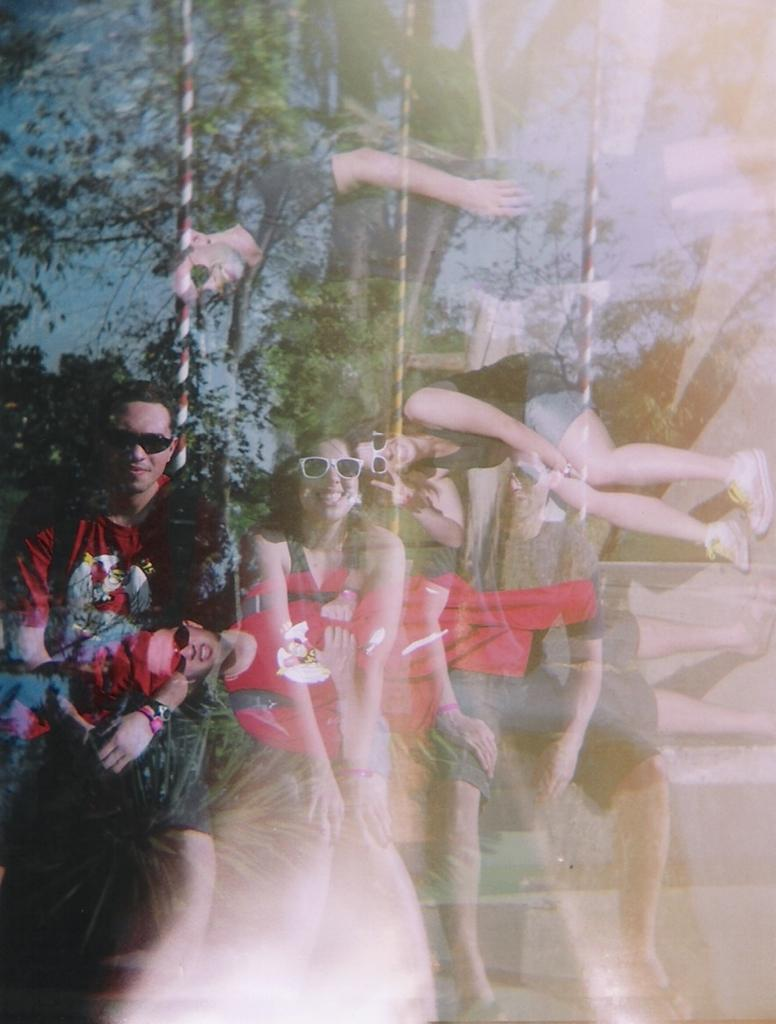What type of surface is present in the image? There is a glass surface in the image. What can be seen reflected on the glass surface? The reflection of trees, persons, and the sky is visible on the glass surface. Can you describe what is visible through the glass surface? There are persons visible through the glass surface. What type of amusement can be seen in the reflection of the sky on the glass surface? There is no amusement visible in the reflection of the sky on the glass surface; it only reflects the sky. 